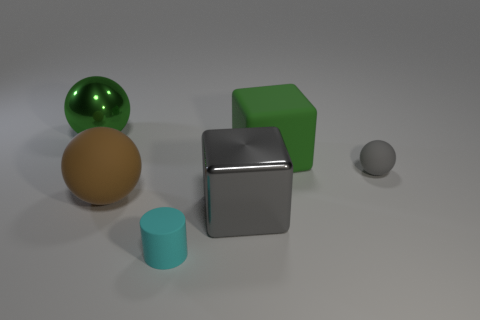There is a tiny rubber thing that is on the left side of the gray ball; what number of rubber things are in front of it?
Provide a succinct answer. 0. What is the material of the gray object that is the same shape as the brown matte object?
Your answer should be compact. Rubber. What number of green objects are balls or big blocks?
Provide a short and direct response. 2. Are there any other things that have the same color as the tiny ball?
Your response must be concise. Yes. The big metal thing in front of the object to the left of the brown matte object is what color?
Provide a succinct answer. Gray. Are there fewer cyan matte cylinders that are behind the tiny cylinder than matte objects that are in front of the large green cube?
Your answer should be compact. Yes. What material is the tiny object that is the same color as the large metallic block?
Ensure brevity in your answer.  Rubber. How many things are either big things that are left of the cyan cylinder or rubber balls?
Offer a very short reply. 3. There is a green thing to the right of the cyan matte object; is it the same size as the brown object?
Provide a short and direct response. Yes. Is the number of tiny cyan rubber objects that are in front of the large rubber block less than the number of green objects?
Ensure brevity in your answer.  Yes. 